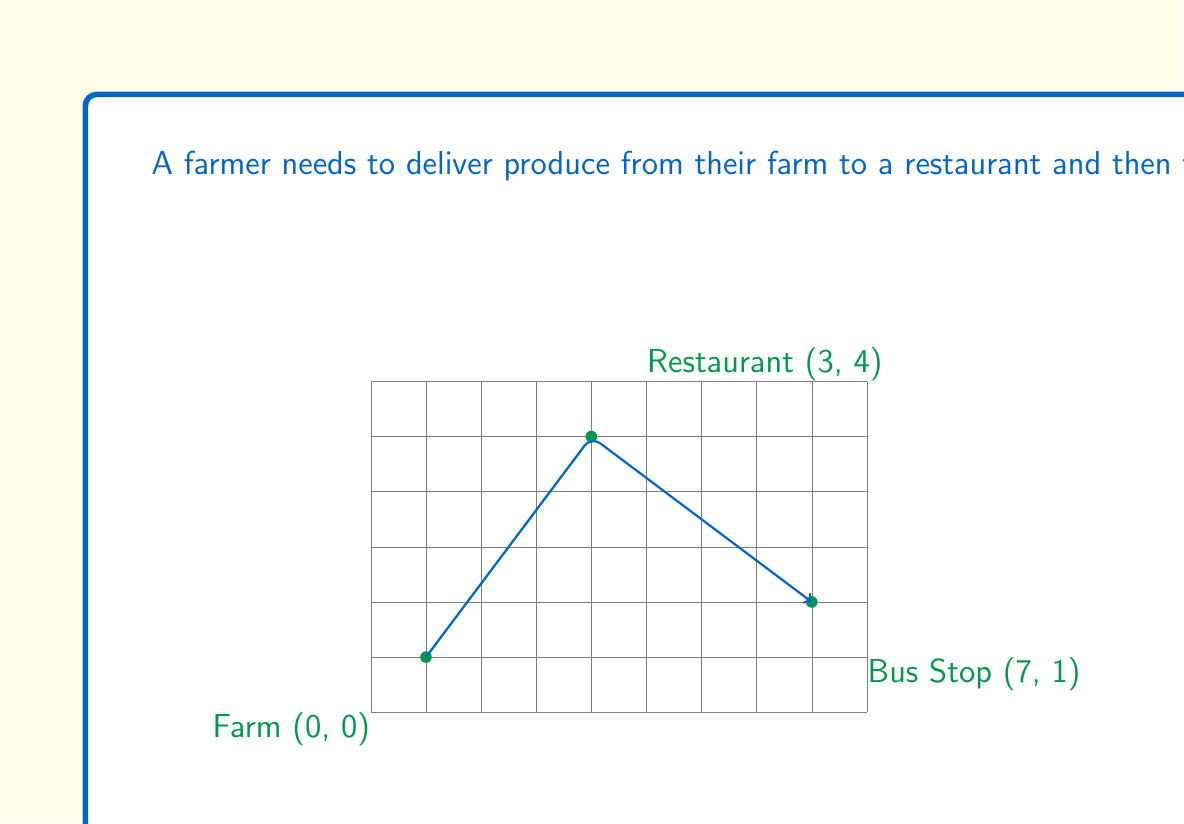Help me with this question. To solve this problem, we need to use the distance formula between two points on a coordinate plane:

$$d = \sqrt{(x_2 - x_1)^2 + (y_2 - y_1)^2}$$

Let's calculate the distances for each leg of the journey:

1. From Farm (0, 0) to Restaurant (3, 4):
   $$d_1 = \sqrt{(3 - 0)^2 + (4 - 0)^2} = \sqrt{9 + 16} = \sqrt{25} = 5 \text{ km}$$

2. From Restaurant (3, 4) to Bus Stop (7, 1):
   $$d_2 = \sqrt{(7 - 3)^2 + (1 - 4)^2} = \sqrt{16 + 9} = \sqrt{25} = 5 \text{ km}$$

The total distance is the sum of these two legs:

$$\text{Total Distance} = d_1 + d_2 = 5 + 5 = 10 \text{ km}$$

Note that this is indeed the shortest path because:
1. The path from the farm to the restaurant is a straight line, which is always the shortest distance between two points.
2. The path from the restaurant to the bus stop is also a straight line.
3. There is no shorter path that could connect all three points in this order.

Rounding to two decimal places gives us 10.00 km.
Answer: 10.00 km 